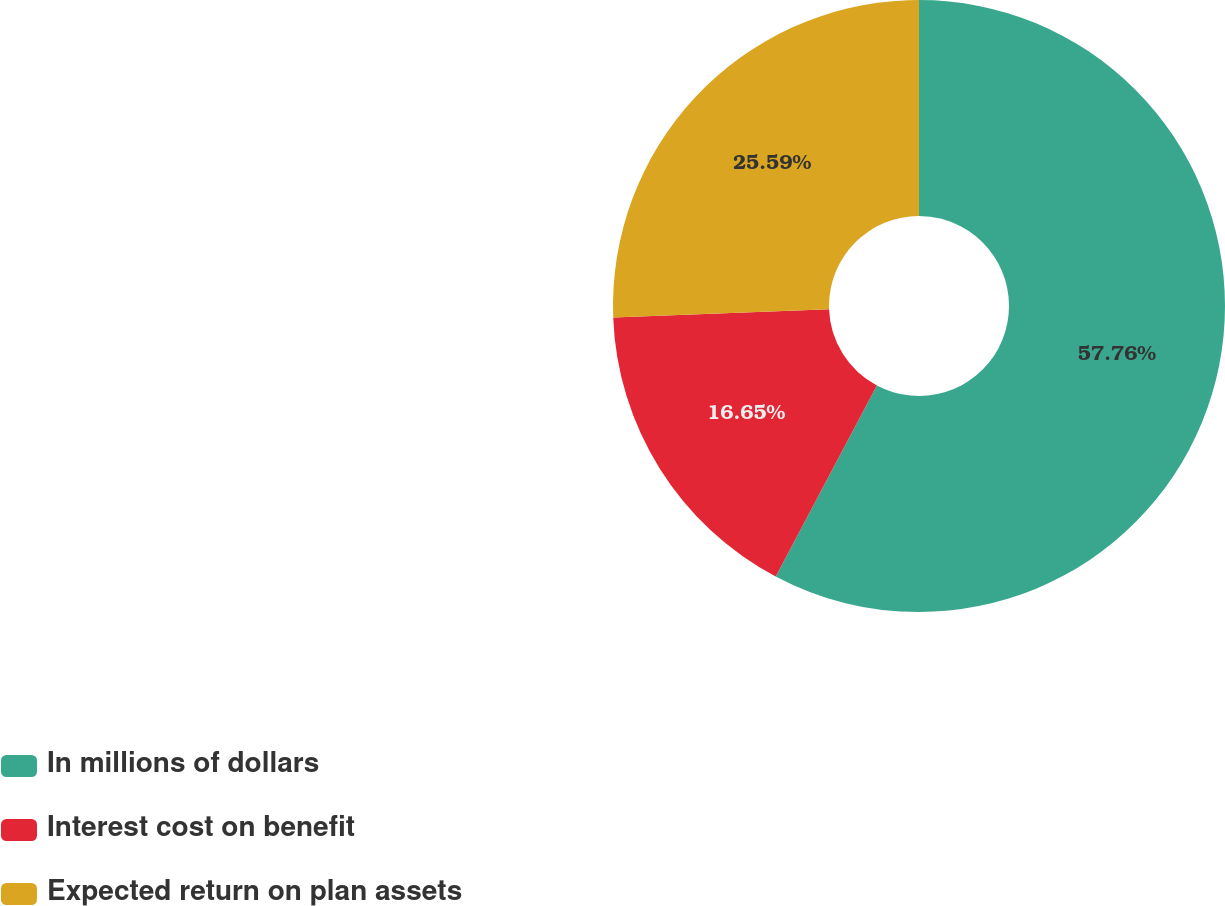<chart> <loc_0><loc_0><loc_500><loc_500><pie_chart><fcel>In millions of dollars<fcel>Interest cost on benefit<fcel>Expected return on plan assets<nl><fcel>57.75%<fcel>16.65%<fcel>25.59%<nl></chart> 